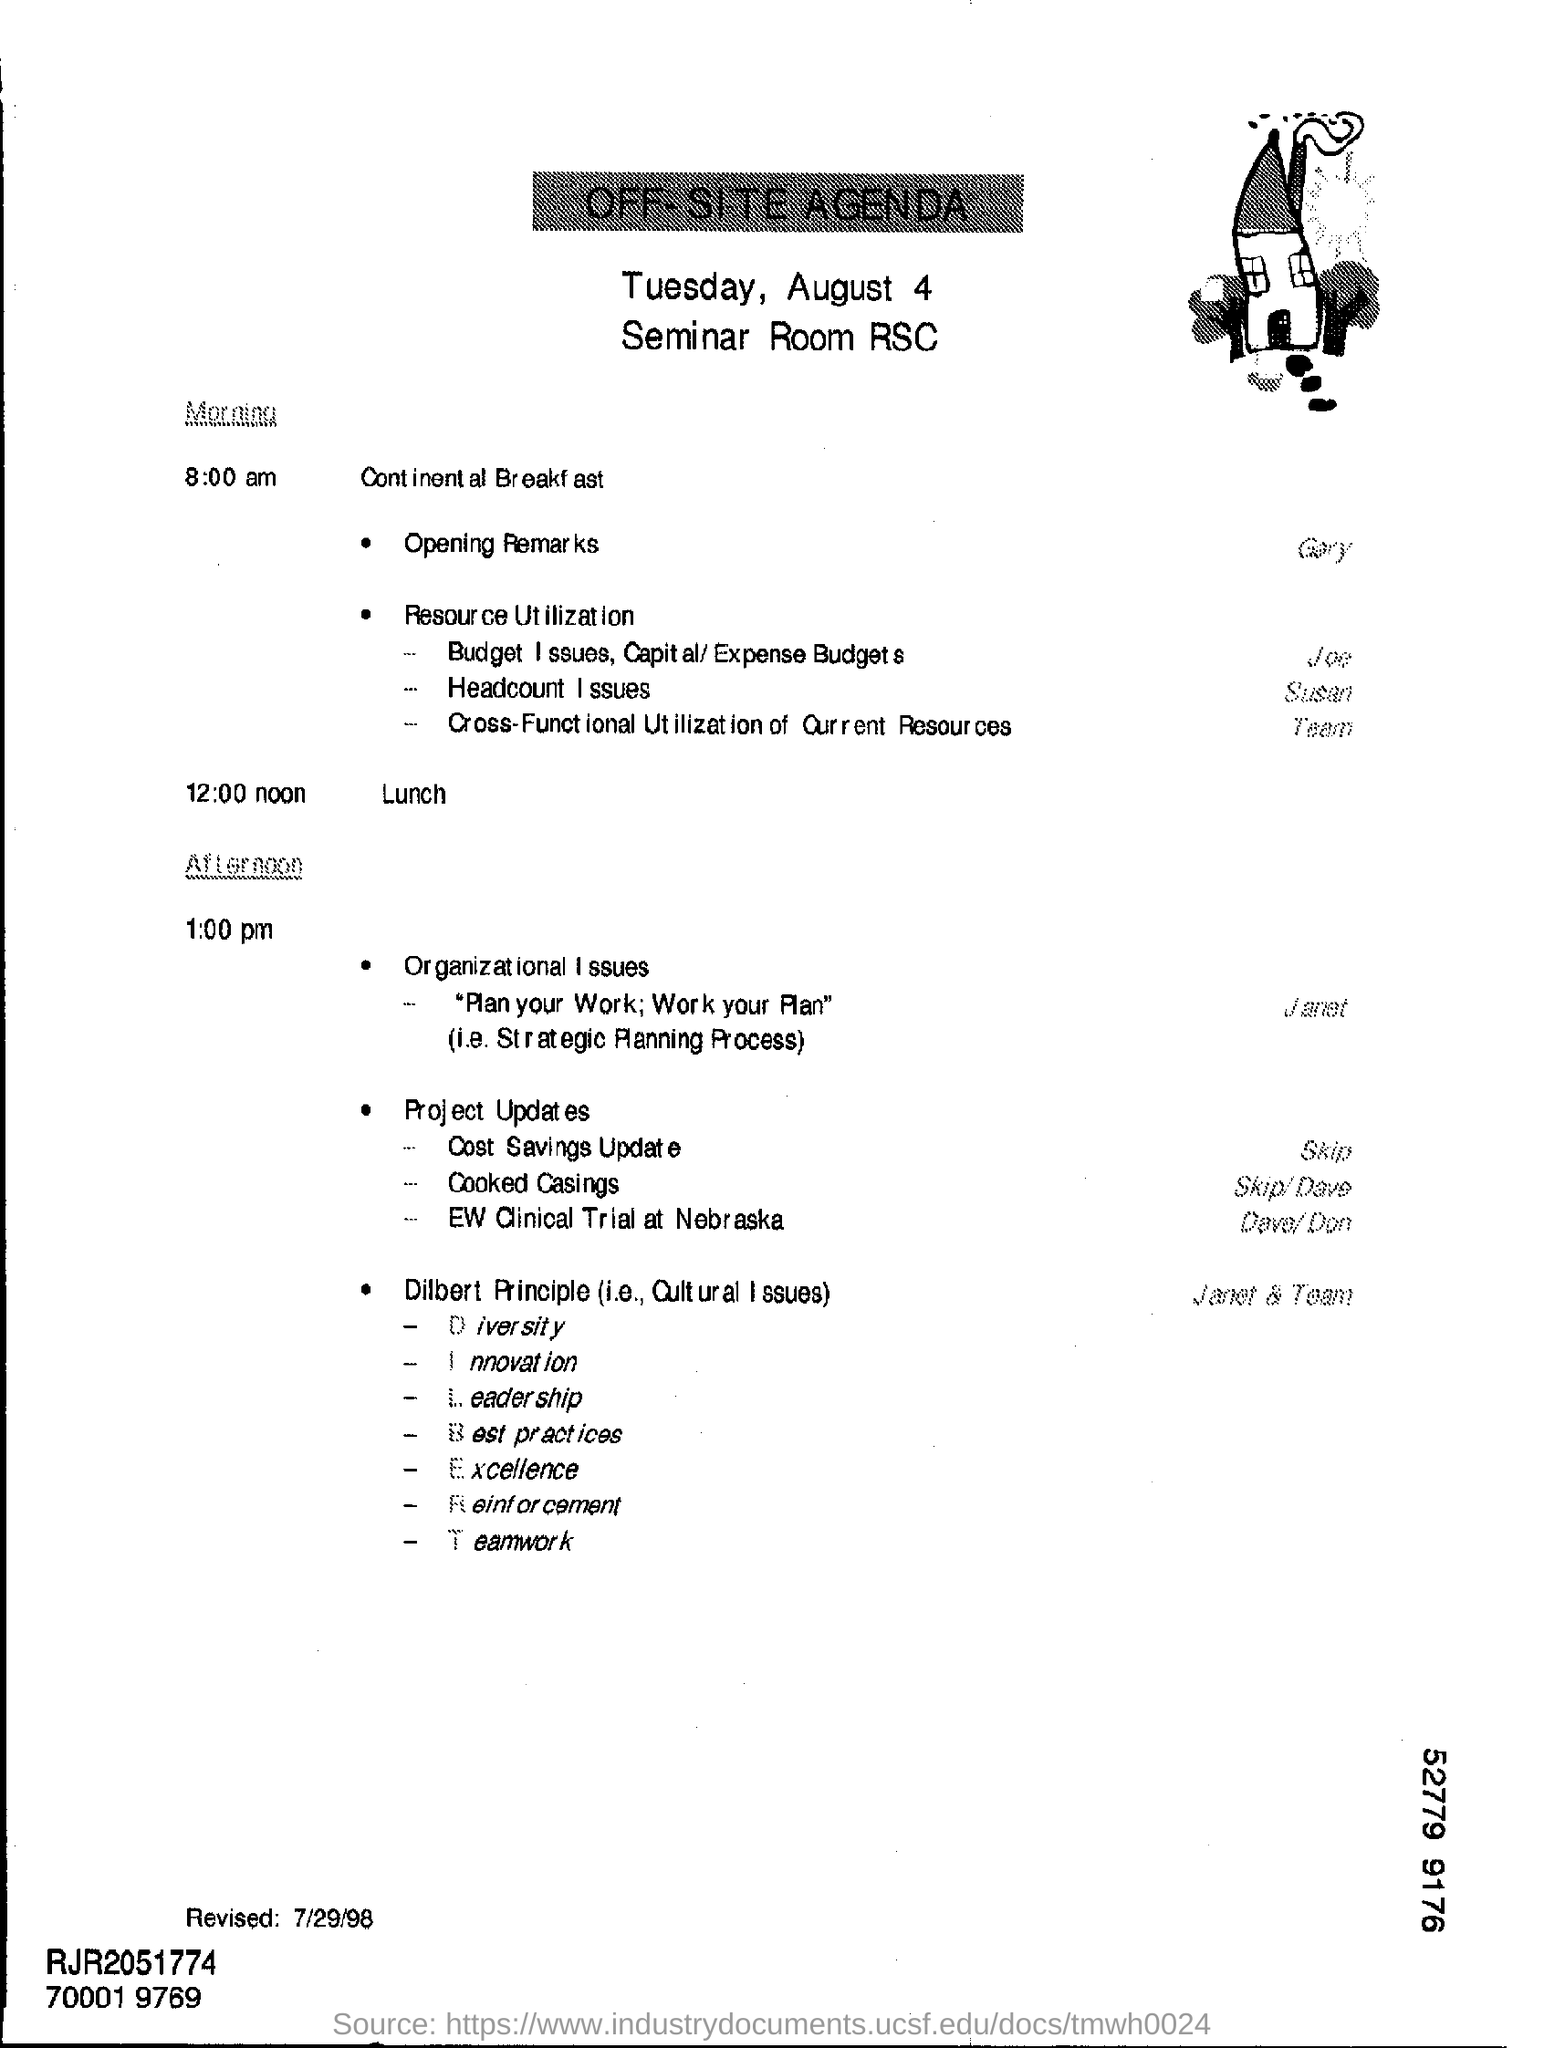Specify some key components in this picture. The date mentioned at the top of the document is Tuesday, August 4th. At 12:00 pm, the time for lunch has arrived. The revised date is July 29, 1998. 